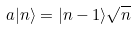<formula> <loc_0><loc_0><loc_500><loc_500>a | n \rangle = | n - 1 \rangle { \sqrt { n } }</formula> 